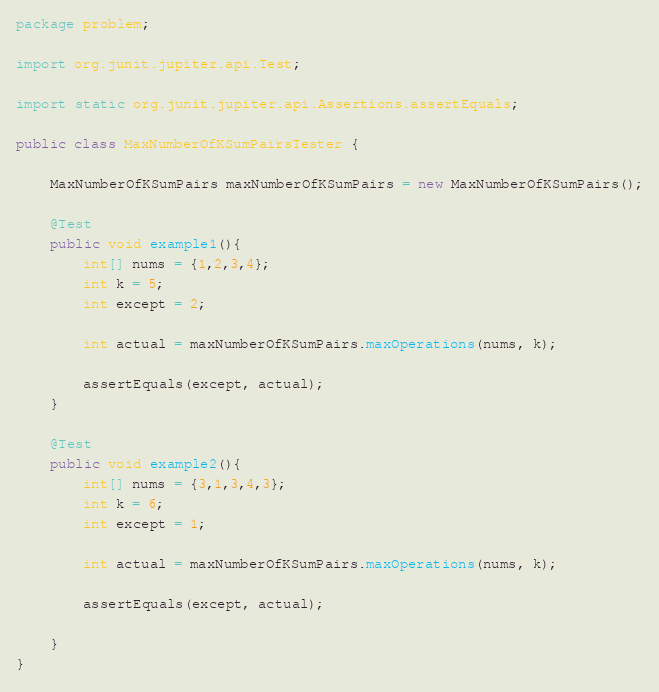<code> <loc_0><loc_0><loc_500><loc_500><_Java_>package problem;

import org.junit.jupiter.api.Test;

import static org.junit.jupiter.api.Assertions.assertEquals;

public class MaxNumberOfKSumPairsTester {

    MaxNumberOfKSumPairs maxNumberOfKSumPairs = new MaxNumberOfKSumPairs();

    @Test
    public void example1(){
        int[] nums = {1,2,3,4};
        int k = 5;
        int except = 2;

        int actual = maxNumberOfKSumPairs.maxOperations(nums, k);

        assertEquals(except, actual);
    }

    @Test
    public void example2(){
        int[] nums = {3,1,3,4,3};
        int k = 6;
        int except = 1;

        int actual = maxNumberOfKSumPairs.maxOperations(nums, k);

        assertEquals(except, actual);

    }
}
</code> 